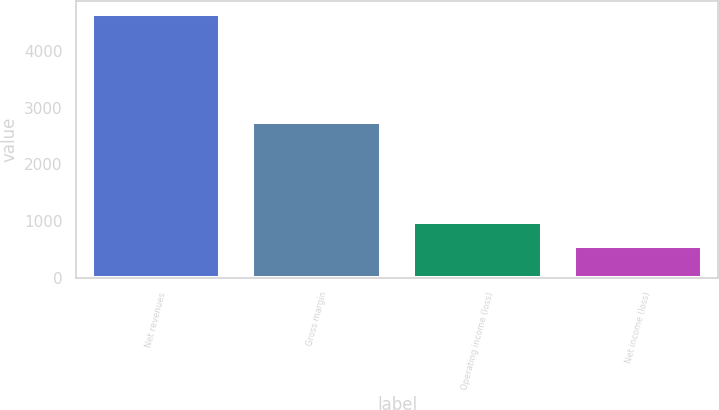Convert chart to OTSL. <chart><loc_0><loc_0><loc_500><loc_500><bar_chart><fcel>Net revenues<fcel>Gross margin<fcel>Operating income (loss)<fcel>Net income (loss)<nl><fcel>4647.5<fcel>2741.2<fcel>974.96<fcel>566.9<nl></chart> 